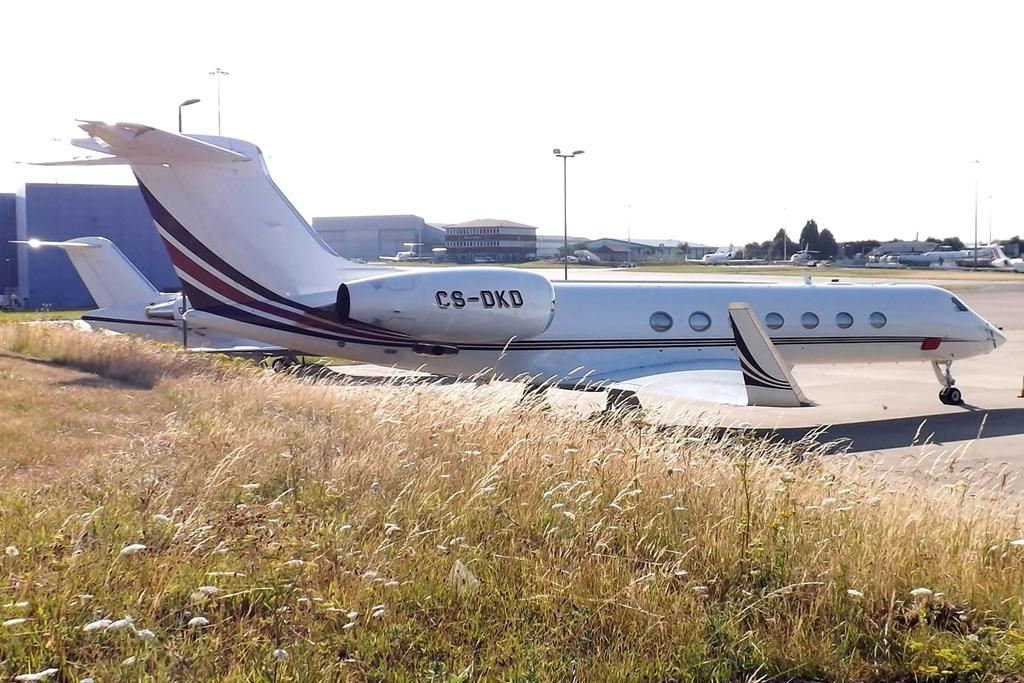<image>
Summarize the visual content of the image. A plane on the tarmac has CS-DKD written on the right-hand engine. 